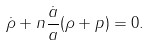<formula> <loc_0><loc_0><loc_500><loc_500>\dot { \rho } + n \frac { \dot { a } } { a } ( \rho + p ) = 0 .</formula> 